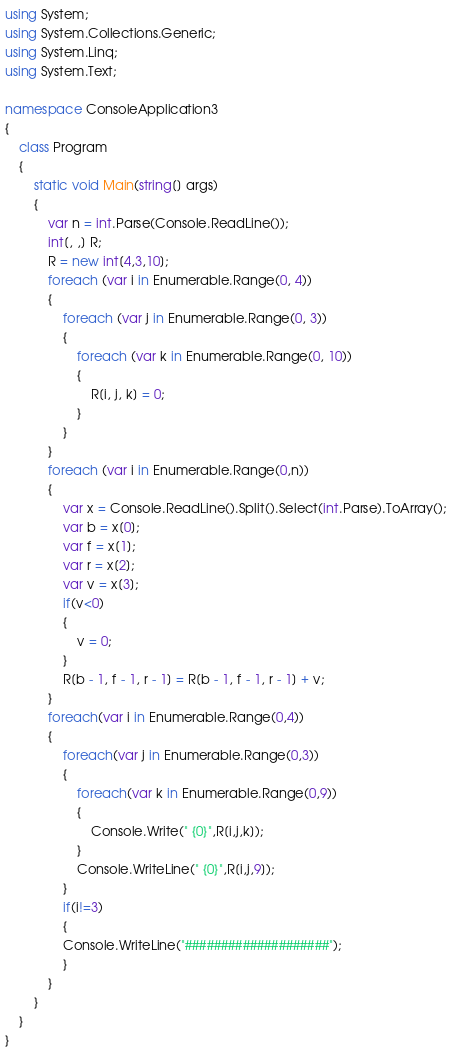Convert code to text. <code><loc_0><loc_0><loc_500><loc_500><_C#_>using System;
using System.Collections.Generic;
using System.Linq;
using System.Text;

namespace ConsoleApplication3
{
    class Program
    {
        static void Main(string[] args)
        {
            var n = int.Parse(Console.ReadLine());
            int[, ,] R;
            R = new int[4,3,10];
            foreach (var i in Enumerable.Range(0, 4))
            {
                foreach (var j in Enumerable.Range(0, 3))
                {
                    foreach (var k in Enumerable.Range(0, 10))
                    {
                        R[i, j, k] = 0;
                    }
                }
            }
            foreach (var i in Enumerable.Range(0,n))
            {
                var x = Console.ReadLine().Split().Select(int.Parse).ToArray();
                var b = x[0];
                var f = x[1];
                var r = x[2];
                var v = x[3];
                if(v<0)
                {
                    v = 0;
                }
                R[b - 1, f - 1, r - 1] = R[b - 1, f - 1, r - 1] + v;
            }
            foreach(var i in Enumerable.Range(0,4))
            {
                foreach(var j in Enumerable.Range(0,3))
                {
                    foreach(var k in Enumerable.Range(0,9))
                    {
                        Console.Write(" {0}",R[i,j,k]);
                    }
                    Console.WriteLine(" {0}",R[i,j,9]);
                }
                if(i!=3)
                {
                Console.WriteLine("####################");
                }
            }
        }
    }
}</code> 